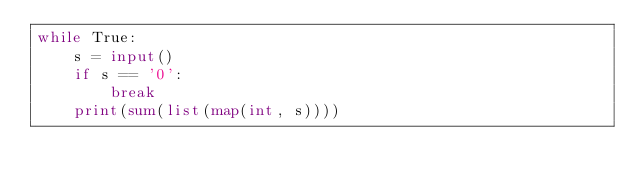Convert code to text. <code><loc_0><loc_0><loc_500><loc_500><_Python_>while True:
    s = input()
    if s == '0':
        break
    print(sum(list(map(int, s))))

</code> 